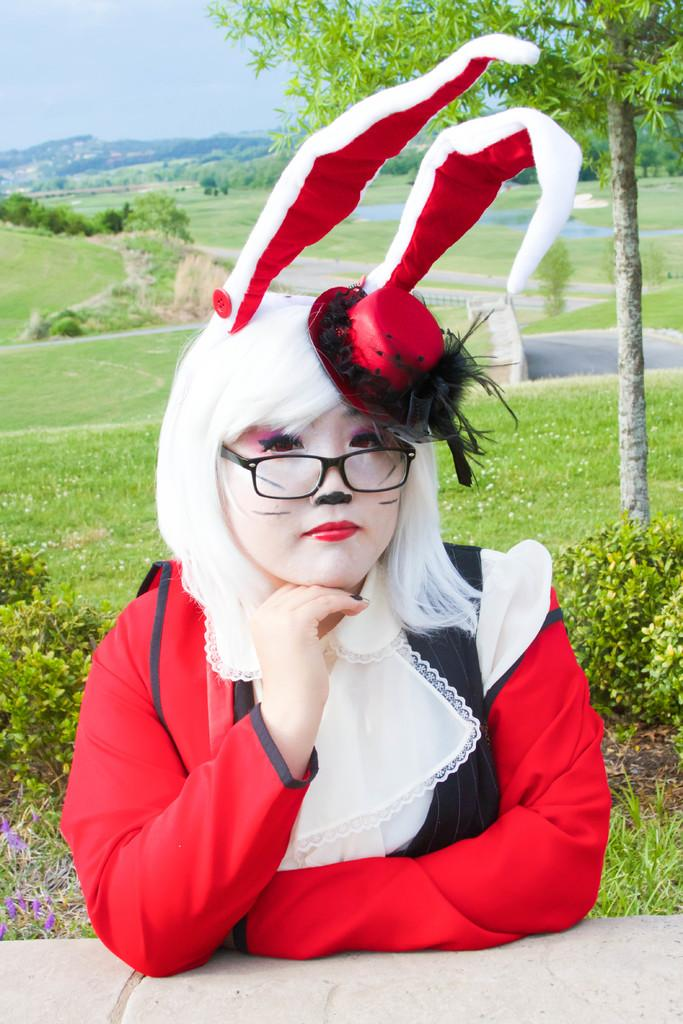What is the lady in the image doing? The lady is sitting in the image. What is the lady wearing? The lady is wearing a red and white dress. What accessory is the lady wearing on her head? The lady has a hairband on her head. What can be seen in the background of the image? The background of the image is grassy land, with trees and plants present. What type of beginner's disease can be seen on the lady's face in the image? There is no mention of any disease or medical condition in the image, and the lady's face appears healthy. 